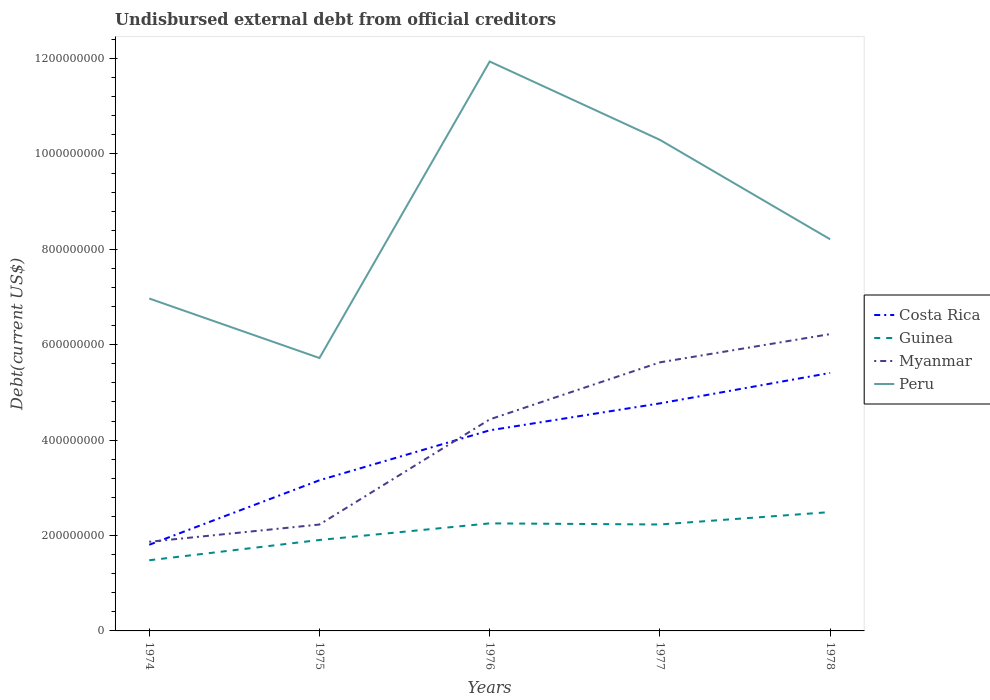Does the line corresponding to Myanmar intersect with the line corresponding to Costa Rica?
Keep it short and to the point. Yes. Across all years, what is the maximum total debt in Guinea?
Your answer should be compact. 1.48e+08. In which year was the total debt in Guinea maximum?
Your answer should be very brief. 1974. What is the total total debt in Peru in the graph?
Your answer should be very brief. -3.33e+08. What is the difference between the highest and the second highest total debt in Costa Rica?
Keep it short and to the point. 3.60e+08. What is the difference between the highest and the lowest total debt in Peru?
Ensure brevity in your answer.  2. Are the values on the major ticks of Y-axis written in scientific E-notation?
Provide a succinct answer. No. How are the legend labels stacked?
Your answer should be compact. Vertical. What is the title of the graph?
Keep it short and to the point. Undisbursed external debt from official creditors. What is the label or title of the X-axis?
Make the answer very short. Years. What is the label or title of the Y-axis?
Your answer should be very brief. Debt(current US$). What is the Debt(current US$) of Costa Rica in 1974?
Your response must be concise. 1.81e+08. What is the Debt(current US$) in Guinea in 1974?
Ensure brevity in your answer.  1.48e+08. What is the Debt(current US$) of Myanmar in 1974?
Your response must be concise. 1.87e+08. What is the Debt(current US$) in Peru in 1974?
Your answer should be very brief. 6.97e+08. What is the Debt(current US$) in Costa Rica in 1975?
Offer a very short reply. 3.16e+08. What is the Debt(current US$) in Guinea in 1975?
Provide a succinct answer. 1.91e+08. What is the Debt(current US$) of Myanmar in 1975?
Your answer should be compact. 2.23e+08. What is the Debt(current US$) of Peru in 1975?
Provide a succinct answer. 5.72e+08. What is the Debt(current US$) of Costa Rica in 1976?
Offer a terse response. 4.21e+08. What is the Debt(current US$) in Guinea in 1976?
Give a very brief answer. 2.25e+08. What is the Debt(current US$) of Myanmar in 1976?
Offer a very short reply. 4.43e+08. What is the Debt(current US$) in Peru in 1976?
Your response must be concise. 1.19e+09. What is the Debt(current US$) of Costa Rica in 1977?
Give a very brief answer. 4.77e+08. What is the Debt(current US$) of Guinea in 1977?
Offer a terse response. 2.23e+08. What is the Debt(current US$) in Myanmar in 1977?
Your response must be concise. 5.63e+08. What is the Debt(current US$) of Peru in 1977?
Ensure brevity in your answer.  1.03e+09. What is the Debt(current US$) in Costa Rica in 1978?
Provide a short and direct response. 5.41e+08. What is the Debt(current US$) of Guinea in 1978?
Offer a very short reply. 2.49e+08. What is the Debt(current US$) of Myanmar in 1978?
Ensure brevity in your answer.  6.22e+08. What is the Debt(current US$) in Peru in 1978?
Offer a terse response. 8.21e+08. Across all years, what is the maximum Debt(current US$) in Costa Rica?
Provide a succinct answer. 5.41e+08. Across all years, what is the maximum Debt(current US$) in Guinea?
Offer a very short reply. 2.49e+08. Across all years, what is the maximum Debt(current US$) of Myanmar?
Make the answer very short. 6.22e+08. Across all years, what is the maximum Debt(current US$) in Peru?
Offer a very short reply. 1.19e+09. Across all years, what is the minimum Debt(current US$) of Costa Rica?
Your answer should be very brief. 1.81e+08. Across all years, what is the minimum Debt(current US$) of Guinea?
Provide a succinct answer. 1.48e+08. Across all years, what is the minimum Debt(current US$) of Myanmar?
Offer a very short reply. 1.87e+08. Across all years, what is the minimum Debt(current US$) in Peru?
Your response must be concise. 5.72e+08. What is the total Debt(current US$) of Costa Rica in the graph?
Ensure brevity in your answer.  1.94e+09. What is the total Debt(current US$) in Guinea in the graph?
Your answer should be very brief. 1.04e+09. What is the total Debt(current US$) in Myanmar in the graph?
Provide a succinct answer. 2.04e+09. What is the total Debt(current US$) of Peru in the graph?
Give a very brief answer. 4.31e+09. What is the difference between the Debt(current US$) in Costa Rica in 1974 and that in 1975?
Provide a short and direct response. -1.35e+08. What is the difference between the Debt(current US$) of Guinea in 1974 and that in 1975?
Your answer should be very brief. -4.25e+07. What is the difference between the Debt(current US$) of Myanmar in 1974 and that in 1975?
Give a very brief answer. -3.62e+07. What is the difference between the Debt(current US$) of Peru in 1974 and that in 1975?
Offer a very short reply. 1.25e+08. What is the difference between the Debt(current US$) in Costa Rica in 1974 and that in 1976?
Offer a very short reply. -2.40e+08. What is the difference between the Debt(current US$) of Guinea in 1974 and that in 1976?
Your answer should be compact. -7.74e+07. What is the difference between the Debt(current US$) of Myanmar in 1974 and that in 1976?
Keep it short and to the point. -2.57e+08. What is the difference between the Debt(current US$) in Peru in 1974 and that in 1976?
Provide a succinct answer. -4.97e+08. What is the difference between the Debt(current US$) in Costa Rica in 1974 and that in 1977?
Make the answer very short. -2.96e+08. What is the difference between the Debt(current US$) of Guinea in 1974 and that in 1977?
Provide a short and direct response. -7.50e+07. What is the difference between the Debt(current US$) of Myanmar in 1974 and that in 1977?
Your answer should be compact. -3.76e+08. What is the difference between the Debt(current US$) of Peru in 1974 and that in 1977?
Keep it short and to the point. -3.33e+08. What is the difference between the Debt(current US$) of Costa Rica in 1974 and that in 1978?
Provide a succinct answer. -3.60e+08. What is the difference between the Debt(current US$) in Guinea in 1974 and that in 1978?
Offer a very short reply. -1.01e+08. What is the difference between the Debt(current US$) in Myanmar in 1974 and that in 1978?
Offer a terse response. -4.35e+08. What is the difference between the Debt(current US$) in Peru in 1974 and that in 1978?
Keep it short and to the point. -1.24e+08. What is the difference between the Debt(current US$) in Costa Rica in 1975 and that in 1976?
Ensure brevity in your answer.  -1.05e+08. What is the difference between the Debt(current US$) in Guinea in 1975 and that in 1976?
Ensure brevity in your answer.  -3.48e+07. What is the difference between the Debt(current US$) in Myanmar in 1975 and that in 1976?
Ensure brevity in your answer.  -2.20e+08. What is the difference between the Debt(current US$) of Peru in 1975 and that in 1976?
Ensure brevity in your answer.  -6.22e+08. What is the difference between the Debt(current US$) in Costa Rica in 1975 and that in 1977?
Keep it short and to the point. -1.61e+08. What is the difference between the Debt(current US$) of Guinea in 1975 and that in 1977?
Ensure brevity in your answer.  -3.25e+07. What is the difference between the Debt(current US$) of Myanmar in 1975 and that in 1977?
Offer a terse response. -3.40e+08. What is the difference between the Debt(current US$) of Peru in 1975 and that in 1977?
Provide a short and direct response. -4.57e+08. What is the difference between the Debt(current US$) in Costa Rica in 1975 and that in 1978?
Ensure brevity in your answer.  -2.25e+08. What is the difference between the Debt(current US$) in Guinea in 1975 and that in 1978?
Keep it short and to the point. -5.85e+07. What is the difference between the Debt(current US$) of Myanmar in 1975 and that in 1978?
Make the answer very short. -3.99e+08. What is the difference between the Debt(current US$) of Peru in 1975 and that in 1978?
Provide a succinct answer. -2.49e+08. What is the difference between the Debt(current US$) in Costa Rica in 1976 and that in 1977?
Offer a very short reply. -5.65e+07. What is the difference between the Debt(current US$) of Guinea in 1976 and that in 1977?
Provide a short and direct response. 2.32e+06. What is the difference between the Debt(current US$) in Myanmar in 1976 and that in 1977?
Your answer should be compact. -1.20e+08. What is the difference between the Debt(current US$) in Peru in 1976 and that in 1977?
Provide a succinct answer. 1.64e+08. What is the difference between the Debt(current US$) in Costa Rica in 1976 and that in 1978?
Provide a succinct answer. -1.20e+08. What is the difference between the Debt(current US$) of Guinea in 1976 and that in 1978?
Offer a very short reply. -2.37e+07. What is the difference between the Debt(current US$) of Myanmar in 1976 and that in 1978?
Keep it short and to the point. -1.79e+08. What is the difference between the Debt(current US$) of Peru in 1976 and that in 1978?
Give a very brief answer. 3.73e+08. What is the difference between the Debt(current US$) of Costa Rica in 1977 and that in 1978?
Offer a very short reply. -6.38e+07. What is the difference between the Debt(current US$) in Guinea in 1977 and that in 1978?
Offer a very short reply. -2.60e+07. What is the difference between the Debt(current US$) in Myanmar in 1977 and that in 1978?
Give a very brief answer. -5.92e+07. What is the difference between the Debt(current US$) in Peru in 1977 and that in 1978?
Keep it short and to the point. 2.09e+08. What is the difference between the Debt(current US$) of Costa Rica in 1974 and the Debt(current US$) of Guinea in 1975?
Keep it short and to the point. -1.01e+07. What is the difference between the Debt(current US$) of Costa Rica in 1974 and the Debt(current US$) of Myanmar in 1975?
Your answer should be very brief. -4.24e+07. What is the difference between the Debt(current US$) of Costa Rica in 1974 and the Debt(current US$) of Peru in 1975?
Offer a terse response. -3.92e+08. What is the difference between the Debt(current US$) of Guinea in 1974 and the Debt(current US$) of Myanmar in 1975?
Provide a short and direct response. -7.49e+07. What is the difference between the Debt(current US$) in Guinea in 1974 and the Debt(current US$) in Peru in 1975?
Provide a short and direct response. -4.24e+08. What is the difference between the Debt(current US$) in Myanmar in 1974 and the Debt(current US$) in Peru in 1975?
Your answer should be compact. -3.85e+08. What is the difference between the Debt(current US$) of Costa Rica in 1974 and the Debt(current US$) of Guinea in 1976?
Make the answer very short. -4.49e+07. What is the difference between the Debt(current US$) in Costa Rica in 1974 and the Debt(current US$) in Myanmar in 1976?
Offer a terse response. -2.63e+08. What is the difference between the Debt(current US$) of Costa Rica in 1974 and the Debt(current US$) of Peru in 1976?
Provide a succinct answer. -1.01e+09. What is the difference between the Debt(current US$) of Guinea in 1974 and the Debt(current US$) of Myanmar in 1976?
Your answer should be compact. -2.95e+08. What is the difference between the Debt(current US$) of Guinea in 1974 and the Debt(current US$) of Peru in 1976?
Your answer should be very brief. -1.05e+09. What is the difference between the Debt(current US$) of Myanmar in 1974 and the Debt(current US$) of Peru in 1976?
Ensure brevity in your answer.  -1.01e+09. What is the difference between the Debt(current US$) in Costa Rica in 1974 and the Debt(current US$) in Guinea in 1977?
Provide a short and direct response. -4.26e+07. What is the difference between the Debt(current US$) in Costa Rica in 1974 and the Debt(current US$) in Myanmar in 1977?
Provide a short and direct response. -3.82e+08. What is the difference between the Debt(current US$) in Costa Rica in 1974 and the Debt(current US$) in Peru in 1977?
Provide a short and direct response. -8.49e+08. What is the difference between the Debt(current US$) in Guinea in 1974 and the Debt(current US$) in Myanmar in 1977?
Provide a succinct answer. -4.15e+08. What is the difference between the Debt(current US$) of Guinea in 1974 and the Debt(current US$) of Peru in 1977?
Offer a very short reply. -8.81e+08. What is the difference between the Debt(current US$) in Myanmar in 1974 and the Debt(current US$) in Peru in 1977?
Give a very brief answer. -8.43e+08. What is the difference between the Debt(current US$) in Costa Rica in 1974 and the Debt(current US$) in Guinea in 1978?
Your response must be concise. -6.86e+07. What is the difference between the Debt(current US$) in Costa Rica in 1974 and the Debt(current US$) in Myanmar in 1978?
Ensure brevity in your answer.  -4.42e+08. What is the difference between the Debt(current US$) of Costa Rica in 1974 and the Debt(current US$) of Peru in 1978?
Your answer should be very brief. -6.40e+08. What is the difference between the Debt(current US$) in Guinea in 1974 and the Debt(current US$) in Myanmar in 1978?
Your response must be concise. -4.74e+08. What is the difference between the Debt(current US$) of Guinea in 1974 and the Debt(current US$) of Peru in 1978?
Your answer should be very brief. -6.73e+08. What is the difference between the Debt(current US$) of Myanmar in 1974 and the Debt(current US$) of Peru in 1978?
Give a very brief answer. -6.34e+08. What is the difference between the Debt(current US$) in Costa Rica in 1975 and the Debt(current US$) in Guinea in 1976?
Provide a short and direct response. 9.04e+07. What is the difference between the Debt(current US$) in Costa Rica in 1975 and the Debt(current US$) in Myanmar in 1976?
Ensure brevity in your answer.  -1.28e+08. What is the difference between the Debt(current US$) of Costa Rica in 1975 and the Debt(current US$) of Peru in 1976?
Offer a terse response. -8.78e+08. What is the difference between the Debt(current US$) in Guinea in 1975 and the Debt(current US$) in Myanmar in 1976?
Make the answer very short. -2.53e+08. What is the difference between the Debt(current US$) in Guinea in 1975 and the Debt(current US$) in Peru in 1976?
Give a very brief answer. -1.00e+09. What is the difference between the Debt(current US$) of Myanmar in 1975 and the Debt(current US$) of Peru in 1976?
Your response must be concise. -9.71e+08. What is the difference between the Debt(current US$) of Costa Rica in 1975 and the Debt(current US$) of Guinea in 1977?
Offer a terse response. 9.27e+07. What is the difference between the Debt(current US$) of Costa Rica in 1975 and the Debt(current US$) of Myanmar in 1977?
Your response must be concise. -2.47e+08. What is the difference between the Debt(current US$) of Costa Rica in 1975 and the Debt(current US$) of Peru in 1977?
Provide a short and direct response. -7.14e+08. What is the difference between the Debt(current US$) of Guinea in 1975 and the Debt(current US$) of Myanmar in 1977?
Ensure brevity in your answer.  -3.72e+08. What is the difference between the Debt(current US$) of Guinea in 1975 and the Debt(current US$) of Peru in 1977?
Your answer should be compact. -8.39e+08. What is the difference between the Debt(current US$) of Myanmar in 1975 and the Debt(current US$) of Peru in 1977?
Offer a terse response. -8.07e+08. What is the difference between the Debt(current US$) of Costa Rica in 1975 and the Debt(current US$) of Guinea in 1978?
Ensure brevity in your answer.  6.67e+07. What is the difference between the Debt(current US$) in Costa Rica in 1975 and the Debt(current US$) in Myanmar in 1978?
Provide a succinct answer. -3.06e+08. What is the difference between the Debt(current US$) of Costa Rica in 1975 and the Debt(current US$) of Peru in 1978?
Ensure brevity in your answer.  -5.05e+08. What is the difference between the Debt(current US$) in Guinea in 1975 and the Debt(current US$) in Myanmar in 1978?
Make the answer very short. -4.32e+08. What is the difference between the Debt(current US$) in Guinea in 1975 and the Debt(current US$) in Peru in 1978?
Give a very brief answer. -6.30e+08. What is the difference between the Debt(current US$) in Myanmar in 1975 and the Debt(current US$) in Peru in 1978?
Your response must be concise. -5.98e+08. What is the difference between the Debt(current US$) of Costa Rica in 1976 and the Debt(current US$) of Guinea in 1977?
Offer a terse response. 1.97e+08. What is the difference between the Debt(current US$) in Costa Rica in 1976 and the Debt(current US$) in Myanmar in 1977?
Offer a very short reply. -1.43e+08. What is the difference between the Debt(current US$) of Costa Rica in 1976 and the Debt(current US$) of Peru in 1977?
Offer a terse response. -6.09e+08. What is the difference between the Debt(current US$) of Guinea in 1976 and the Debt(current US$) of Myanmar in 1977?
Your answer should be very brief. -3.38e+08. What is the difference between the Debt(current US$) in Guinea in 1976 and the Debt(current US$) in Peru in 1977?
Offer a very short reply. -8.04e+08. What is the difference between the Debt(current US$) of Myanmar in 1976 and the Debt(current US$) of Peru in 1977?
Offer a terse response. -5.86e+08. What is the difference between the Debt(current US$) in Costa Rica in 1976 and the Debt(current US$) in Guinea in 1978?
Offer a terse response. 1.71e+08. What is the difference between the Debt(current US$) of Costa Rica in 1976 and the Debt(current US$) of Myanmar in 1978?
Make the answer very short. -2.02e+08. What is the difference between the Debt(current US$) of Costa Rica in 1976 and the Debt(current US$) of Peru in 1978?
Provide a short and direct response. -4.00e+08. What is the difference between the Debt(current US$) of Guinea in 1976 and the Debt(current US$) of Myanmar in 1978?
Ensure brevity in your answer.  -3.97e+08. What is the difference between the Debt(current US$) in Guinea in 1976 and the Debt(current US$) in Peru in 1978?
Keep it short and to the point. -5.96e+08. What is the difference between the Debt(current US$) in Myanmar in 1976 and the Debt(current US$) in Peru in 1978?
Your answer should be compact. -3.78e+08. What is the difference between the Debt(current US$) in Costa Rica in 1977 and the Debt(current US$) in Guinea in 1978?
Your answer should be very brief. 2.28e+08. What is the difference between the Debt(current US$) in Costa Rica in 1977 and the Debt(current US$) in Myanmar in 1978?
Offer a terse response. -1.45e+08. What is the difference between the Debt(current US$) in Costa Rica in 1977 and the Debt(current US$) in Peru in 1978?
Your answer should be compact. -3.44e+08. What is the difference between the Debt(current US$) in Guinea in 1977 and the Debt(current US$) in Myanmar in 1978?
Provide a succinct answer. -3.99e+08. What is the difference between the Debt(current US$) in Guinea in 1977 and the Debt(current US$) in Peru in 1978?
Give a very brief answer. -5.98e+08. What is the difference between the Debt(current US$) of Myanmar in 1977 and the Debt(current US$) of Peru in 1978?
Give a very brief answer. -2.58e+08. What is the average Debt(current US$) of Costa Rica per year?
Give a very brief answer. 3.87e+08. What is the average Debt(current US$) in Guinea per year?
Make the answer very short. 2.07e+08. What is the average Debt(current US$) in Myanmar per year?
Your response must be concise. 4.08e+08. What is the average Debt(current US$) in Peru per year?
Make the answer very short. 8.63e+08. In the year 1974, what is the difference between the Debt(current US$) of Costa Rica and Debt(current US$) of Guinea?
Keep it short and to the point. 3.25e+07. In the year 1974, what is the difference between the Debt(current US$) in Costa Rica and Debt(current US$) in Myanmar?
Offer a terse response. -6.26e+06. In the year 1974, what is the difference between the Debt(current US$) of Costa Rica and Debt(current US$) of Peru?
Offer a very short reply. -5.16e+08. In the year 1974, what is the difference between the Debt(current US$) of Guinea and Debt(current US$) of Myanmar?
Your answer should be compact. -3.87e+07. In the year 1974, what is the difference between the Debt(current US$) of Guinea and Debt(current US$) of Peru?
Your response must be concise. -5.49e+08. In the year 1974, what is the difference between the Debt(current US$) in Myanmar and Debt(current US$) in Peru?
Ensure brevity in your answer.  -5.10e+08. In the year 1975, what is the difference between the Debt(current US$) of Costa Rica and Debt(current US$) of Guinea?
Provide a succinct answer. 1.25e+08. In the year 1975, what is the difference between the Debt(current US$) in Costa Rica and Debt(current US$) in Myanmar?
Your answer should be compact. 9.28e+07. In the year 1975, what is the difference between the Debt(current US$) of Costa Rica and Debt(current US$) of Peru?
Offer a very short reply. -2.56e+08. In the year 1975, what is the difference between the Debt(current US$) of Guinea and Debt(current US$) of Myanmar?
Keep it short and to the point. -3.24e+07. In the year 1975, what is the difference between the Debt(current US$) of Guinea and Debt(current US$) of Peru?
Keep it short and to the point. -3.81e+08. In the year 1975, what is the difference between the Debt(current US$) of Myanmar and Debt(current US$) of Peru?
Provide a succinct answer. -3.49e+08. In the year 1976, what is the difference between the Debt(current US$) of Costa Rica and Debt(current US$) of Guinea?
Give a very brief answer. 1.95e+08. In the year 1976, what is the difference between the Debt(current US$) of Costa Rica and Debt(current US$) of Myanmar?
Offer a very short reply. -2.29e+07. In the year 1976, what is the difference between the Debt(current US$) of Costa Rica and Debt(current US$) of Peru?
Provide a succinct answer. -7.73e+08. In the year 1976, what is the difference between the Debt(current US$) of Guinea and Debt(current US$) of Myanmar?
Your answer should be compact. -2.18e+08. In the year 1976, what is the difference between the Debt(current US$) in Guinea and Debt(current US$) in Peru?
Ensure brevity in your answer.  -9.68e+08. In the year 1976, what is the difference between the Debt(current US$) of Myanmar and Debt(current US$) of Peru?
Make the answer very short. -7.50e+08. In the year 1977, what is the difference between the Debt(current US$) of Costa Rica and Debt(current US$) of Guinea?
Provide a short and direct response. 2.54e+08. In the year 1977, what is the difference between the Debt(current US$) of Costa Rica and Debt(current US$) of Myanmar?
Make the answer very short. -8.60e+07. In the year 1977, what is the difference between the Debt(current US$) in Costa Rica and Debt(current US$) in Peru?
Give a very brief answer. -5.52e+08. In the year 1977, what is the difference between the Debt(current US$) in Guinea and Debt(current US$) in Myanmar?
Your answer should be very brief. -3.40e+08. In the year 1977, what is the difference between the Debt(current US$) of Guinea and Debt(current US$) of Peru?
Keep it short and to the point. -8.06e+08. In the year 1977, what is the difference between the Debt(current US$) of Myanmar and Debt(current US$) of Peru?
Make the answer very short. -4.66e+08. In the year 1978, what is the difference between the Debt(current US$) in Costa Rica and Debt(current US$) in Guinea?
Your answer should be very brief. 2.92e+08. In the year 1978, what is the difference between the Debt(current US$) of Costa Rica and Debt(current US$) of Myanmar?
Provide a succinct answer. -8.14e+07. In the year 1978, what is the difference between the Debt(current US$) in Costa Rica and Debt(current US$) in Peru?
Give a very brief answer. -2.80e+08. In the year 1978, what is the difference between the Debt(current US$) of Guinea and Debt(current US$) of Myanmar?
Your answer should be compact. -3.73e+08. In the year 1978, what is the difference between the Debt(current US$) in Guinea and Debt(current US$) in Peru?
Provide a succinct answer. -5.72e+08. In the year 1978, what is the difference between the Debt(current US$) of Myanmar and Debt(current US$) of Peru?
Offer a very short reply. -1.99e+08. What is the ratio of the Debt(current US$) in Costa Rica in 1974 to that in 1975?
Offer a terse response. 0.57. What is the ratio of the Debt(current US$) of Guinea in 1974 to that in 1975?
Keep it short and to the point. 0.78. What is the ratio of the Debt(current US$) of Myanmar in 1974 to that in 1975?
Your answer should be very brief. 0.84. What is the ratio of the Debt(current US$) of Peru in 1974 to that in 1975?
Your answer should be very brief. 1.22. What is the ratio of the Debt(current US$) of Costa Rica in 1974 to that in 1976?
Your response must be concise. 0.43. What is the ratio of the Debt(current US$) of Guinea in 1974 to that in 1976?
Your answer should be very brief. 0.66. What is the ratio of the Debt(current US$) of Myanmar in 1974 to that in 1976?
Offer a terse response. 0.42. What is the ratio of the Debt(current US$) of Peru in 1974 to that in 1976?
Keep it short and to the point. 0.58. What is the ratio of the Debt(current US$) in Costa Rica in 1974 to that in 1977?
Your answer should be compact. 0.38. What is the ratio of the Debt(current US$) of Guinea in 1974 to that in 1977?
Give a very brief answer. 0.66. What is the ratio of the Debt(current US$) of Myanmar in 1974 to that in 1977?
Make the answer very short. 0.33. What is the ratio of the Debt(current US$) of Peru in 1974 to that in 1977?
Offer a very short reply. 0.68. What is the ratio of the Debt(current US$) of Costa Rica in 1974 to that in 1978?
Make the answer very short. 0.33. What is the ratio of the Debt(current US$) in Guinea in 1974 to that in 1978?
Keep it short and to the point. 0.59. What is the ratio of the Debt(current US$) of Myanmar in 1974 to that in 1978?
Offer a terse response. 0.3. What is the ratio of the Debt(current US$) of Peru in 1974 to that in 1978?
Your response must be concise. 0.85. What is the ratio of the Debt(current US$) of Costa Rica in 1975 to that in 1976?
Your answer should be compact. 0.75. What is the ratio of the Debt(current US$) in Guinea in 1975 to that in 1976?
Keep it short and to the point. 0.85. What is the ratio of the Debt(current US$) of Myanmar in 1975 to that in 1976?
Your answer should be very brief. 0.5. What is the ratio of the Debt(current US$) of Peru in 1975 to that in 1976?
Keep it short and to the point. 0.48. What is the ratio of the Debt(current US$) of Costa Rica in 1975 to that in 1977?
Provide a short and direct response. 0.66. What is the ratio of the Debt(current US$) of Guinea in 1975 to that in 1977?
Make the answer very short. 0.85. What is the ratio of the Debt(current US$) of Myanmar in 1975 to that in 1977?
Your response must be concise. 0.4. What is the ratio of the Debt(current US$) of Peru in 1975 to that in 1977?
Provide a succinct answer. 0.56. What is the ratio of the Debt(current US$) in Costa Rica in 1975 to that in 1978?
Make the answer very short. 0.58. What is the ratio of the Debt(current US$) of Guinea in 1975 to that in 1978?
Give a very brief answer. 0.77. What is the ratio of the Debt(current US$) in Myanmar in 1975 to that in 1978?
Keep it short and to the point. 0.36. What is the ratio of the Debt(current US$) in Peru in 1975 to that in 1978?
Your response must be concise. 0.7. What is the ratio of the Debt(current US$) of Costa Rica in 1976 to that in 1977?
Offer a very short reply. 0.88. What is the ratio of the Debt(current US$) of Guinea in 1976 to that in 1977?
Give a very brief answer. 1.01. What is the ratio of the Debt(current US$) of Myanmar in 1976 to that in 1977?
Your answer should be compact. 0.79. What is the ratio of the Debt(current US$) of Peru in 1976 to that in 1977?
Your response must be concise. 1.16. What is the ratio of the Debt(current US$) of Costa Rica in 1976 to that in 1978?
Keep it short and to the point. 0.78. What is the ratio of the Debt(current US$) in Guinea in 1976 to that in 1978?
Keep it short and to the point. 0.91. What is the ratio of the Debt(current US$) of Myanmar in 1976 to that in 1978?
Provide a short and direct response. 0.71. What is the ratio of the Debt(current US$) of Peru in 1976 to that in 1978?
Provide a short and direct response. 1.45. What is the ratio of the Debt(current US$) in Costa Rica in 1977 to that in 1978?
Provide a succinct answer. 0.88. What is the ratio of the Debt(current US$) of Guinea in 1977 to that in 1978?
Your answer should be compact. 0.9. What is the ratio of the Debt(current US$) of Myanmar in 1977 to that in 1978?
Provide a succinct answer. 0.9. What is the ratio of the Debt(current US$) of Peru in 1977 to that in 1978?
Keep it short and to the point. 1.25. What is the difference between the highest and the second highest Debt(current US$) in Costa Rica?
Provide a succinct answer. 6.38e+07. What is the difference between the highest and the second highest Debt(current US$) in Guinea?
Your answer should be compact. 2.37e+07. What is the difference between the highest and the second highest Debt(current US$) of Myanmar?
Give a very brief answer. 5.92e+07. What is the difference between the highest and the second highest Debt(current US$) of Peru?
Give a very brief answer. 1.64e+08. What is the difference between the highest and the lowest Debt(current US$) of Costa Rica?
Offer a terse response. 3.60e+08. What is the difference between the highest and the lowest Debt(current US$) of Guinea?
Keep it short and to the point. 1.01e+08. What is the difference between the highest and the lowest Debt(current US$) of Myanmar?
Give a very brief answer. 4.35e+08. What is the difference between the highest and the lowest Debt(current US$) of Peru?
Provide a short and direct response. 6.22e+08. 